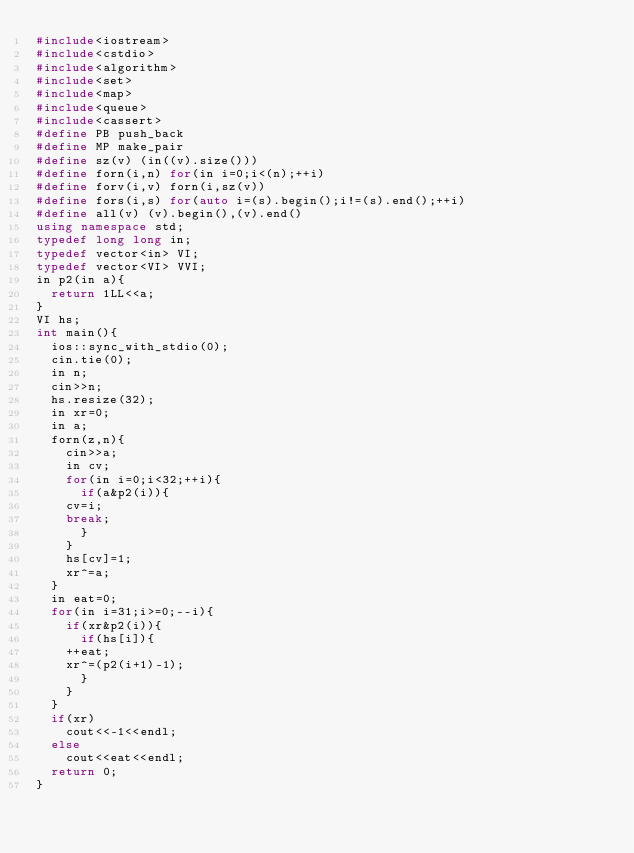Convert code to text. <code><loc_0><loc_0><loc_500><loc_500><_C++_>#include<iostream>
#include<cstdio>
#include<algorithm>
#include<set>
#include<map>
#include<queue>
#include<cassert>
#define PB push_back
#define MP make_pair
#define sz(v) (in((v).size()))
#define forn(i,n) for(in i=0;i<(n);++i)
#define forv(i,v) forn(i,sz(v))
#define fors(i,s) for(auto i=(s).begin();i!=(s).end();++i)
#define all(v) (v).begin(),(v).end()
using namespace std;
typedef long long in;
typedef vector<in> VI;
typedef vector<VI> VVI;
in p2(in a){
  return 1LL<<a;
}
VI hs;
int main(){
  ios::sync_with_stdio(0);
  cin.tie(0);
  in n;
  cin>>n;
  hs.resize(32);
  in xr=0;
  in a;
  forn(z,n){
    cin>>a;
    in cv;
    for(in i=0;i<32;++i){
      if(a&p2(i)){
	cv=i;
	break;
      }
    }
    hs[cv]=1;
    xr^=a;
  }
  in eat=0;
  for(in i=31;i>=0;--i){
    if(xr&p2(i)){
      if(hs[i]){
	++eat;
	xr^=(p2(i+1)-1);
      }
    }
  }
  if(xr)
    cout<<-1<<endl;
  else
    cout<<eat<<endl;
  return 0;
}
</code> 